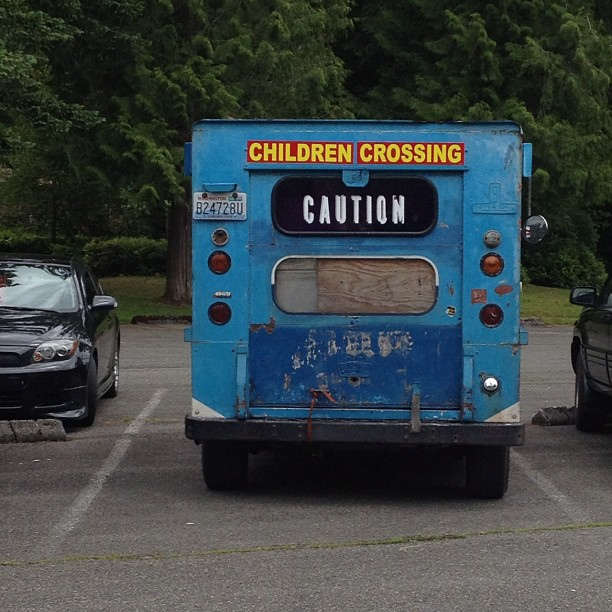<image>Why is this truck stopped? I don't know why the truck is stopped. It might be parked. Why is this truck stopped? The truck is stopped because it is parked. 